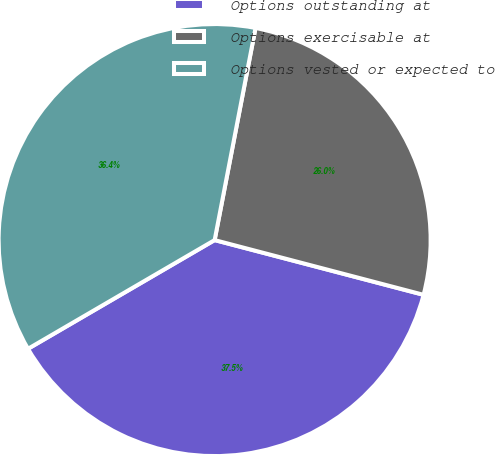Convert chart to OTSL. <chart><loc_0><loc_0><loc_500><loc_500><pie_chart><fcel>Options outstanding at<fcel>Options exercisable at<fcel>Options vested or expected to<nl><fcel>37.53%<fcel>26.05%<fcel>36.43%<nl></chart> 